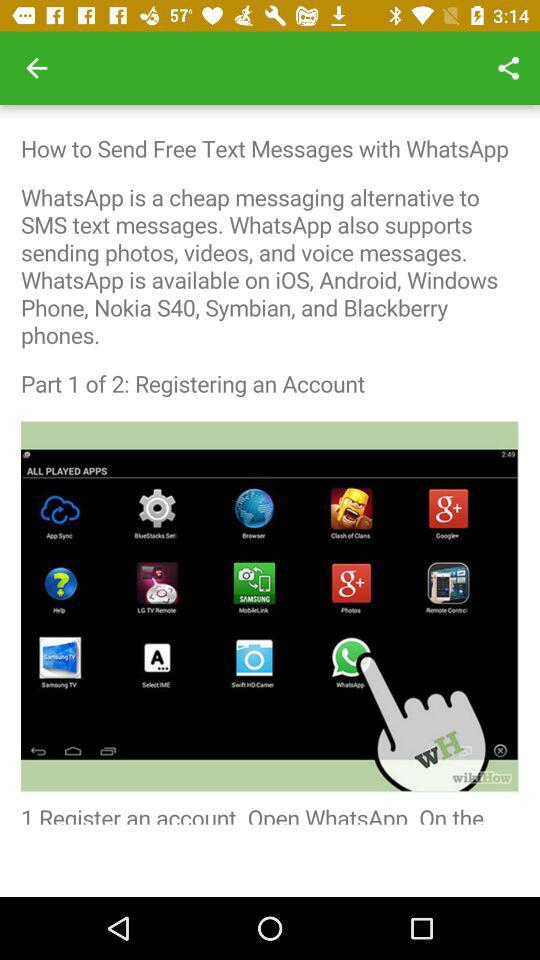What is the total part to send a free message?
When the provided information is insufficient, respond with <no answer>. <no answer> 